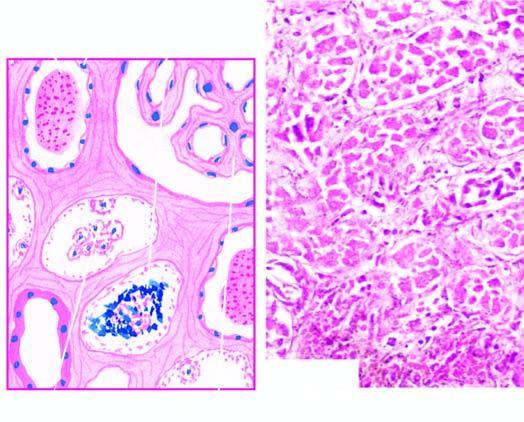what is there of epithelial cells involving predominantly proximal convoluted tubule diffusely?
Answer the question using a single word or phrase. Extensive necrosis 